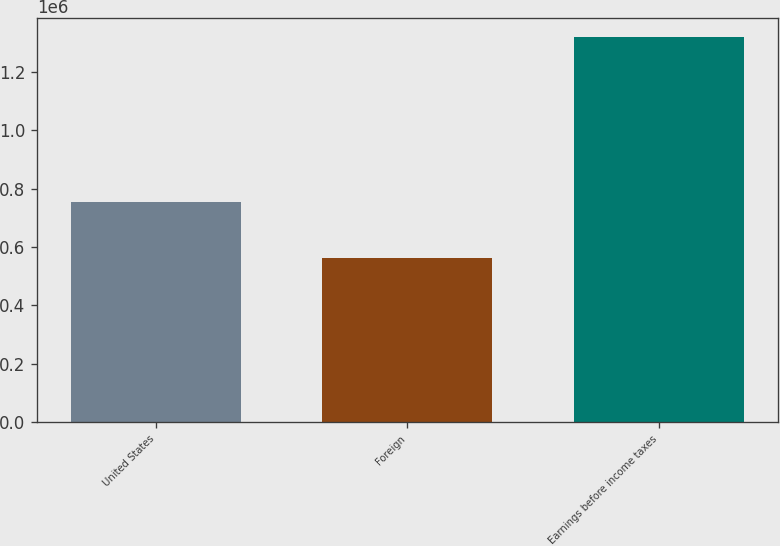<chart> <loc_0><loc_0><loc_500><loc_500><bar_chart><fcel>United States<fcel>Foreign<fcel>Earnings before income taxes<nl><fcel>754562<fcel>563295<fcel>1.31786e+06<nl></chart> 